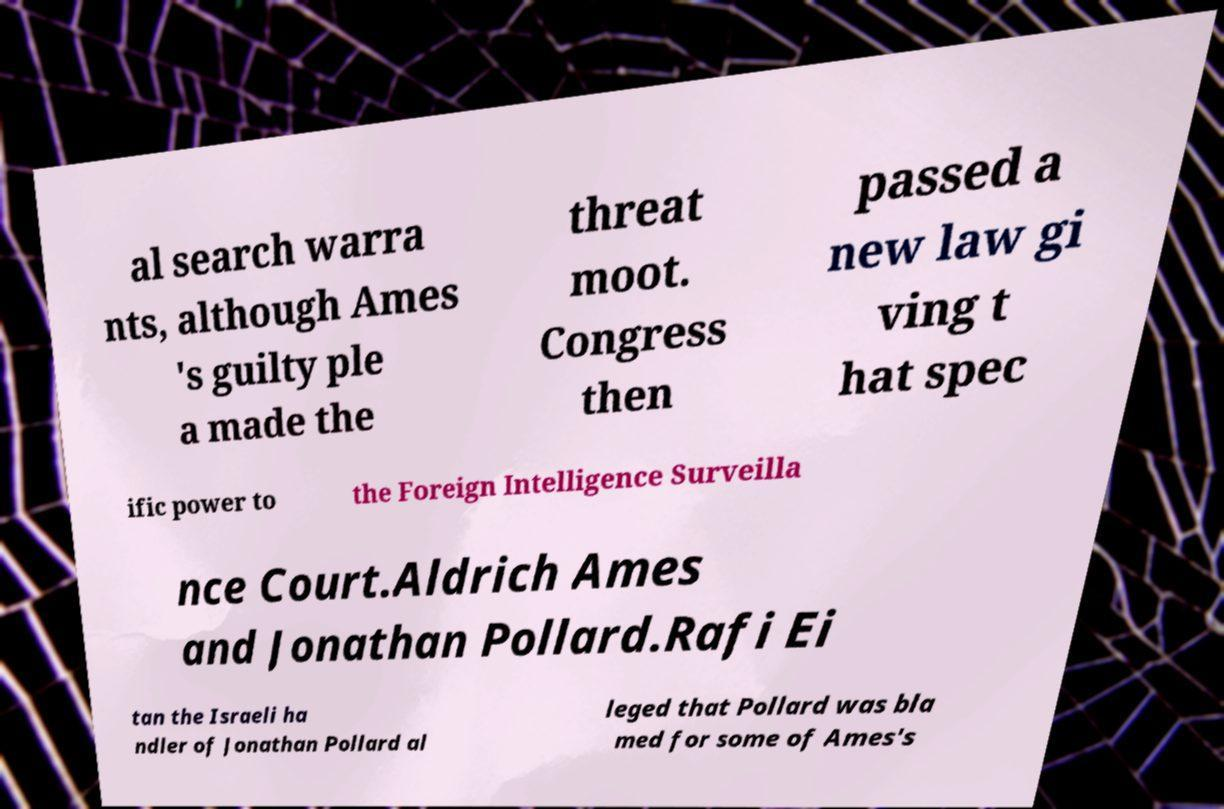Please identify and transcribe the text found in this image. al search warra nts, although Ames 's guilty ple a made the threat moot. Congress then passed a new law gi ving t hat spec ific power to the Foreign Intelligence Surveilla nce Court.Aldrich Ames and Jonathan Pollard.Rafi Ei tan the Israeli ha ndler of Jonathan Pollard al leged that Pollard was bla med for some of Ames's 